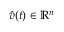Convert formula to latex. <formula><loc_0><loc_0><loc_500><loc_500>{ \hat { v } } ( t ) \in { \mathbb { R } } ^ { n }</formula> 